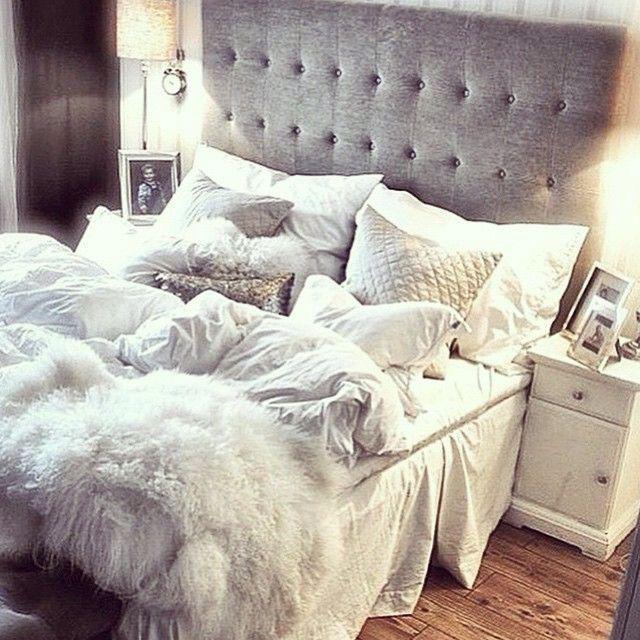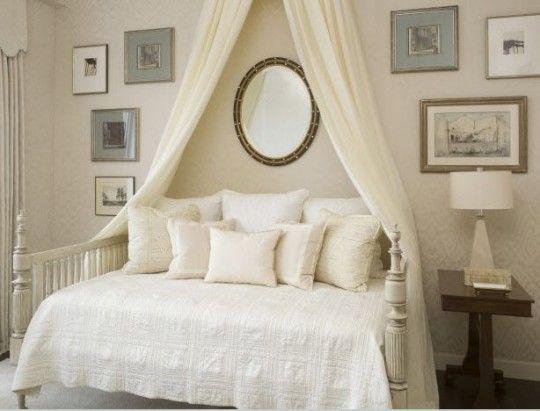The first image is the image on the left, the second image is the image on the right. Evaluate the accuracy of this statement regarding the images: "One bed has an upholstered headboard.". Is it true? Answer yes or no. Yes. 